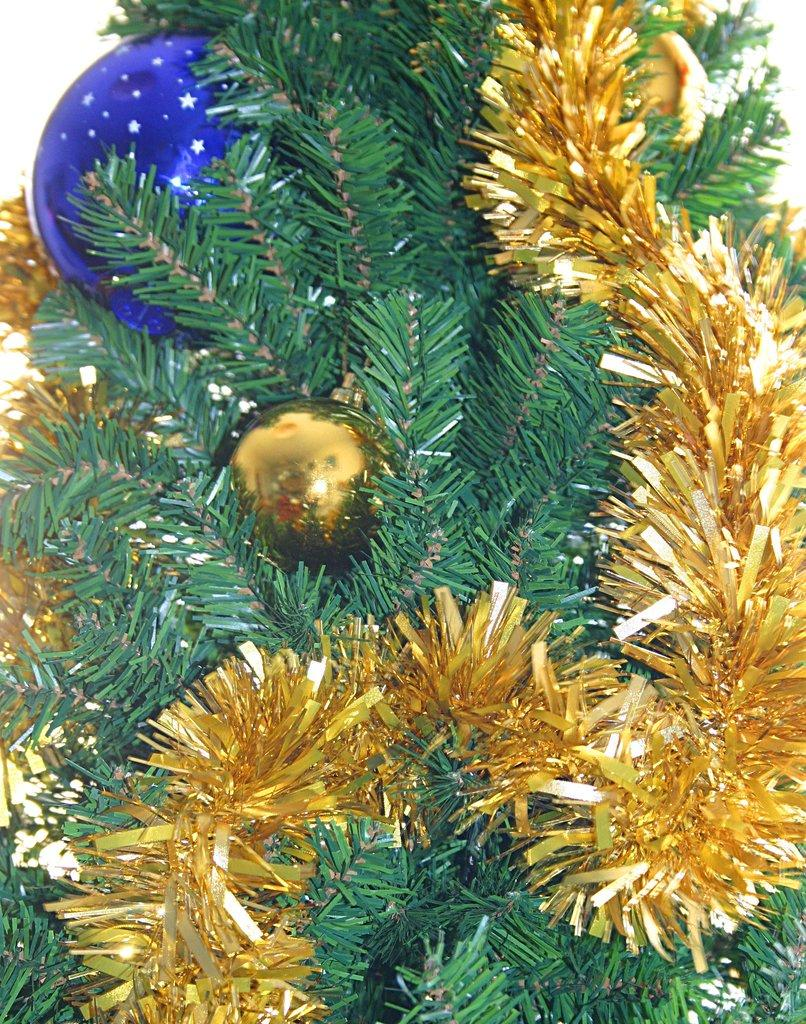What type of tree is in the image? There is a Christmas tree in the image. What decoration can be seen on the Christmas tree? There is a ball on the Christmas tree. Can you describe another object on the Christmas tree? There is an object on the Christmas tree, but its specific details are not mentioned in the facts. How long does the laborer take to give a haircut in the image? There is no laborer or haircut present in the image; it features a Christmas tree with a ball and an unspecified object. 